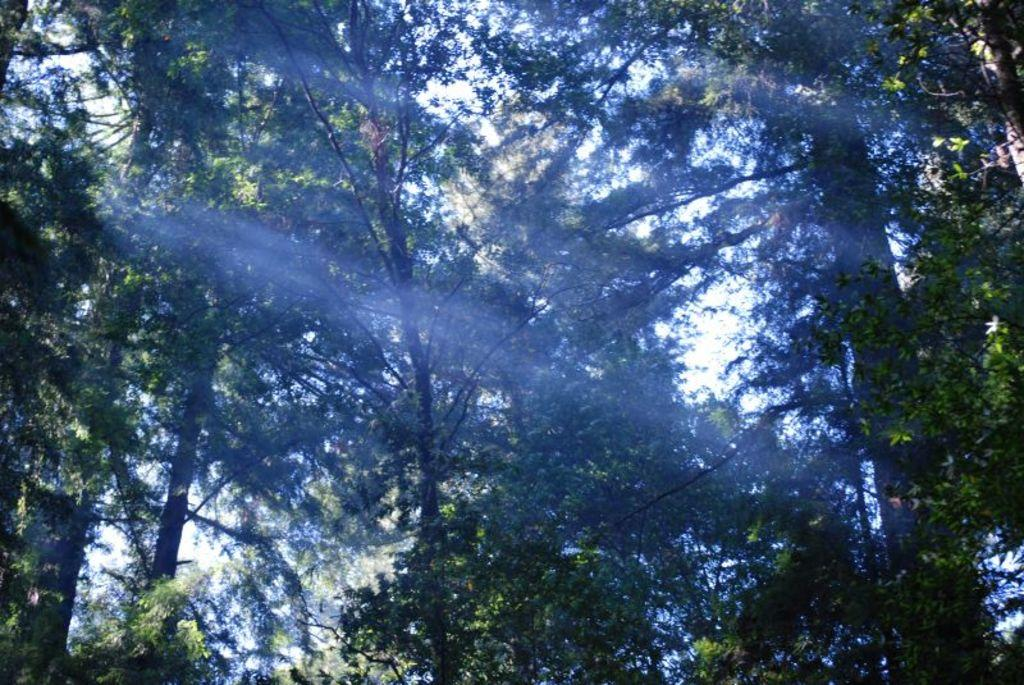What is the main subject of the image? The main subject of the image is a group of trees. How many trees are visible in the image? There are many trees in the center of the image. What can be inferred about the setting of the image? The presence of trees suggests that the image may have been taken in a natural or forested area. What reason does the board give for stopping in the image? There is no board or reason for stopping present in the image; it only features a group of trees. 